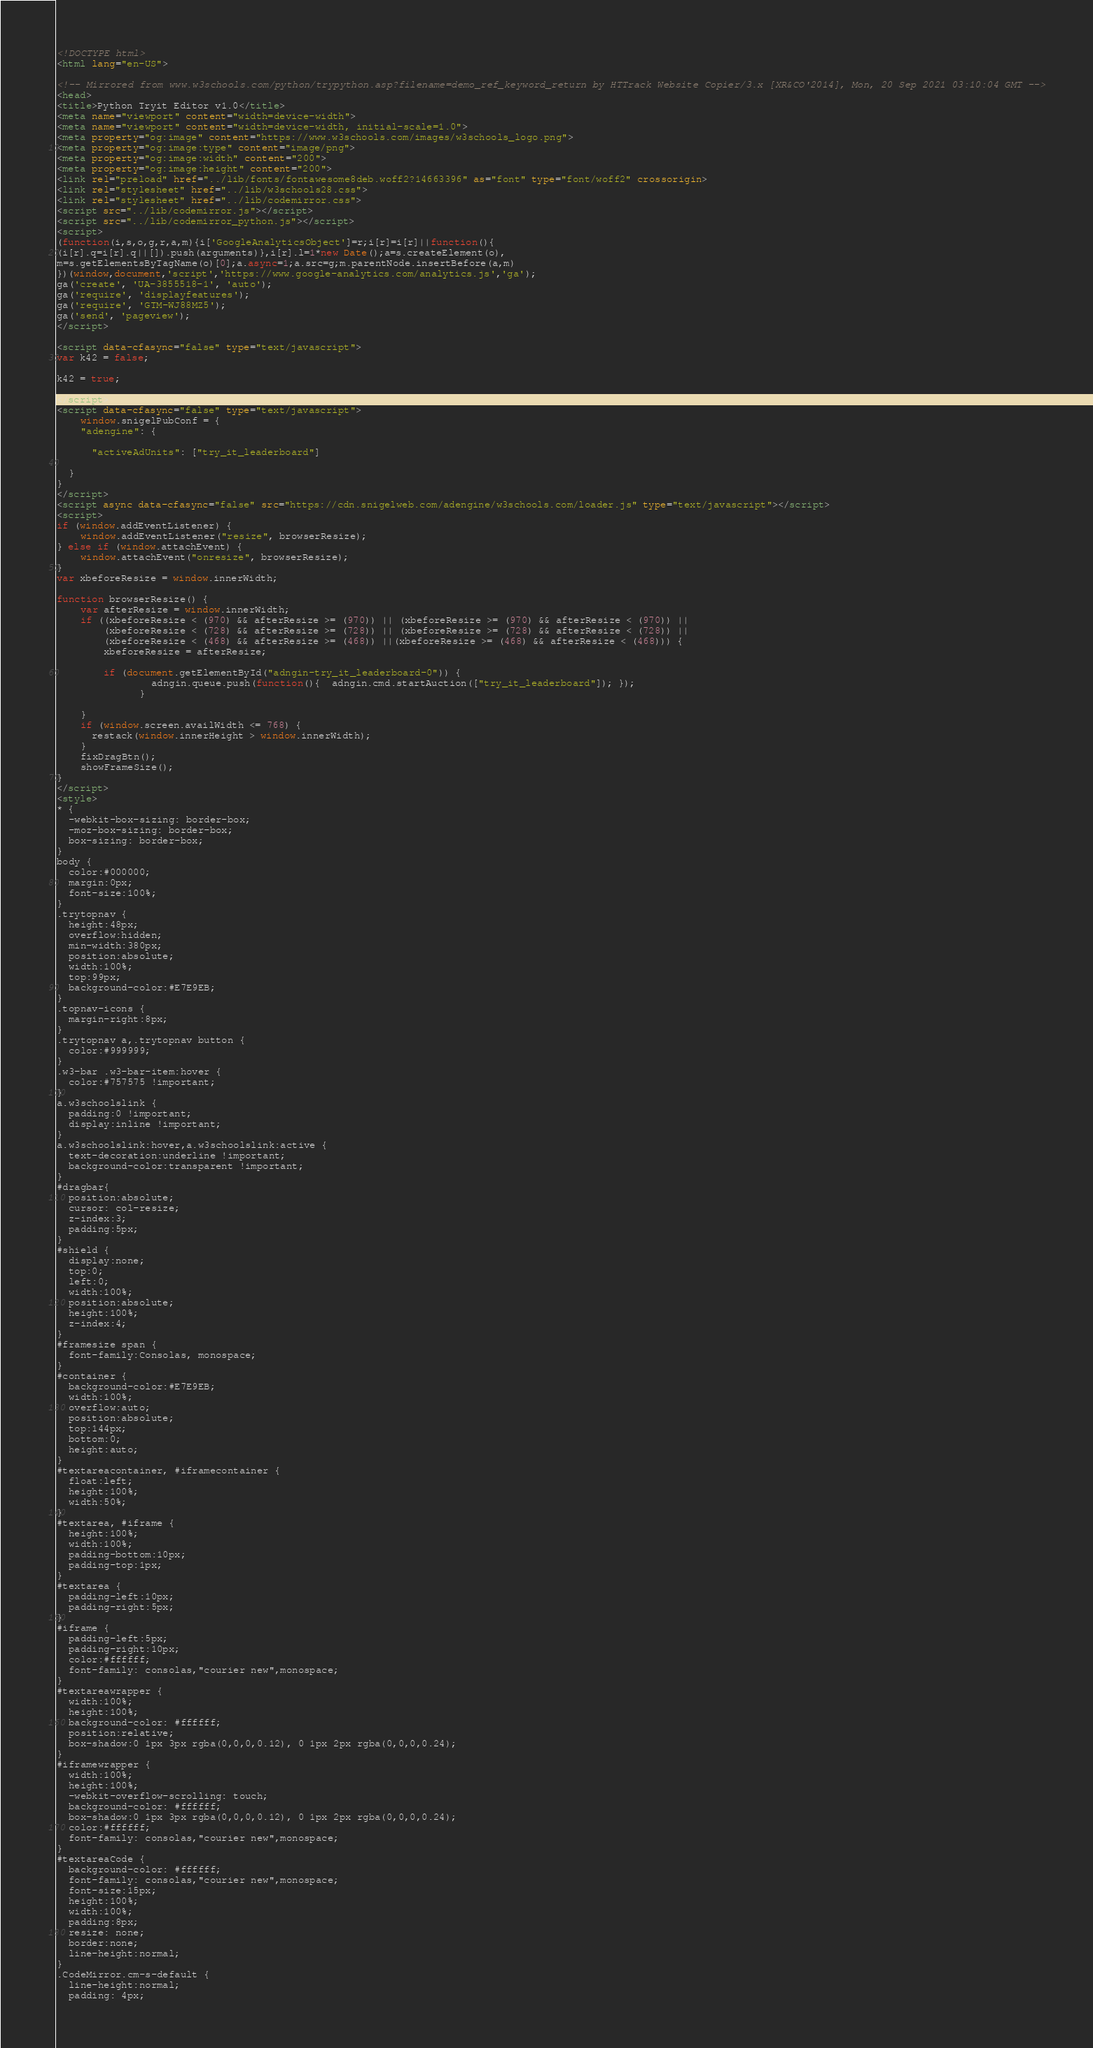<code> <loc_0><loc_0><loc_500><loc_500><_HTML_>
<!DOCTYPE html>
<html lang="en-US">

<!-- Mirrored from www.w3schools.com/python/trypython.asp?filename=demo_ref_keyword_return by HTTrack Website Copier/3.x [XR&CO'2014], Mon, 20 Sep 2021 03:10:04 GMT -->
<head>
<title>Python Tryit Editor v1.0</title>
<meta name="viewport" content="width=device-width">
<meta name="viewport" content="width=device-width, initial-scale=1.0">
<meta property="og:image" content="https://www.w3schools.com/images/w3schools_logo.png">
<meta property="og:image:type" content="image/png">
<meta property="og:image:width" content="200">
<meta property="og:image:height" content="200">
<link rel="preload" href="../lib/fonts/fontawesome8deb.woff2?14663396" as="font" type="font/woff2" crossorigin> 
<link rel="stylesheet" href="../lib/w3schools28.css">
<link rel="stylesheet" href="../lib/codemirror.css">
<script src="../lib/codemirror.js"></script>
<script src="../lib/codemirror_python.js"></script>
<script>
(function(i,s,o,g,r,a,m){i['GoogleAnalyticsObject']=r;i[r]=i[r]||function(){
(i[r].q=i[r].q||[]).push(arguments)},i[r].l=1*new Date();a=s.createElement(o),
m=s.getElementsByTagName(o)[0];a.async=1;a.src=g;m.parentNode.insertBefore(a,m)
})(window,document,'script','https://www.google-analytics.com/analytics.js','ga');
ga('create', 'UA-3855518-1', 'auto');
ga('require', 'displayfeatures');
ga('require', 'GTM-WJ88MZ5');
ga('send', 'pageview');
</script>

<script data-cfasync="false" type="text/javascript">
var k42 = false;

k42 = true;

</script>
<script data-cfasync="false" type="text/javascript">
    window.snigelPubConf = {
    "adengine": {

      "activeAdUnits": ["try_it_leaderboard"]

  }
}
</script>
<script async data-cfasync="false" src="https://cdn.snigelweb.com/adengine/w3schools.com/loader.js" type="text/javascript"></script>
<script>
if (window.addEventListener) {              
    window.addEventListener("resize", browserResize);
} else if (window.attachEvent) {                 
    window.attachEvent("onresize", browserResize);
}
var xbeforeResize = window.innerWidth;

function browserResize() {
    var afterResize = window.innerWidth;
    if ((xbeforeResize < (970) && afterResize >= (970)) || (xbeforeResize >= (970) && afterResize < (970)) ||
        (xbeforeResize < (728) && afterResize >= (728)) || (xbeforeResize >= (728) && afterResize < (728)) ||
        (xbeforeResize < (468) && afterResize >= (468)) ||(xbeforeResize >= (468) && afterResize < (468))) {
        xbeforeResize = afterResize;
        
        if (document.getElementById("adngin-try_it_leaderboard-0")) {
                adngin.queue.push(function(){  adngin.cmd.startAuction(["try_it_leaderboard"]); });
              }
         
    }
    if (window.screen.availWidth <= 768) {
      restack(window.innerHeight > window.innerWidth);
    }
    fixDragBtn();
    showFrameSize();    
}
</script>
<style>
* {
  -webkit-box-sizing: border-box;
  -moz-box-sizing: border-box;
  box-sizing: border-box;
}
body {
  color:#000000;
  margin:0px;
  font-size:100%;
}
.trytopnav {
  height:48px;
  overflow:hidden;
  min-width:380px;
  position:absolute;
  width:100%;
  top:99px;
  background-color:#E7E9EB;
}
.topnav-icons {
  margin-right:8px;
}
.trytopnav a,.trytopnav button {
  color:#999999;
}
.w3-bar .w3-bar-item:hover {
  color:#757575 !important;
}
a.w3schoolslink {
  padding:0 !important;
  display:inline !important;
}
a.w3schoolslink:hover,a.w3schoolslink:active {
  text-decoration:underline !important;
  background-color:transparent !important;
}
#dragbar{
  position:absolute;
  cursor: col-resize;
  z-index:3;
  padding:5px;
}
#shield {
  display:none;
  top:0;
  left:0;
  width:100%;
  position:absolute;
  height:100%;
  z-index:4;
}
#framesize span {
  font-family:Consolas, monospace;
}
#container {
  background-color:#E7E9EB;
  width:100%;
  overflow:auto;
  position:absolute;
  top:144px;
  bottom:0;
  height:auto;
}
#textareacontainer, #iframecontainer {
  float:left;
  height:100%;
  width:50%;
}
#textarea, #iframe {
  height:100%;
  width:100%;
  padding-bottom:10px;
  padding-top:1px;
}
#textarea {
  padding-left:10px;
  padding-right:5px;  
}
#iframe {
  padding-left:5px;
  padding-right:10px;
  color:#ffffff;
  font-family: consolas,"courier new",monospace;    
}
#textareawrapper {
  width:100%;
  height:100%;
  background-color: #ffffff;
  position:relative;
  box-shadow:0 1px 3px rgba(0,0,0,0.12), 0 1px 2px rgba(0,0,0,0.24);
}
#iframewrapper {
  width:100%;
  height:100%;
  -webkit-overflow-scrolling: touch;
  background-color: #ffffff;
  box-shadow:0 1px 3px rgba(0,0,0,0.12), 0 1px 2px rgba(0,0,0,0.24);
  color:#ffffff;
  font-family: consolas,"courier new",monospace;  
}
#textareaCode {
  background-color: #ffffff;
  font-family: consolas,"courier new",monospace;
  font-size:15px;
  height:100%;
  width:100%;
  padding:8px;
  resize: none;
  border:none;
  line-height:normal;    
}
.CodeMirror.cm-s-default {
  line-height:normal;
  padding: 4px;</code> 